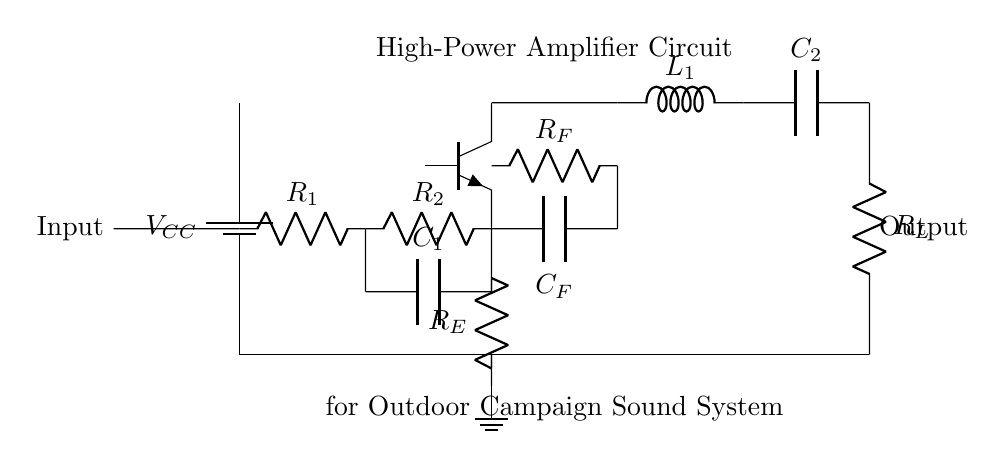What type of transistor is used in this amplifier circuit? The circuit diagram shows a transistor labeled as 'Q1' with a designation of 'Tnpn', indicating that it is a NPN transistor, which is typically used for amplifying signals in such circuits.
Answer: NPN What is the purpose of capacitor C1 in this circuit? Capacitor C1 connects in parallel with resistor R2, and it serves to block DC voltage while allowing AC signals to pass, which is essential for coupling the input signal to the transistor for amplification.
Answer: Coupling What does the symbol L1 represent in the output stage? The symbol L1 in the output stage denotes an inductor, which is used for filtering high-frequency noise from the output signal, ensuring a cleaner sound for the outdoor campaign sound system.
Answer: Inductor What is the minimum voltage required across the battery in this circuit? The circuit diagram does not specify an exact voltage; however, in general, for a high-power amplifier using NPN transistors, a minimum battery voltage of 12V to 15V is often needed to ensure proper operation and headroom for the output stages.
Answer: Twelve volts Why is resistor Rf connected in the feedback network? Resistor Rf is part of the feedback network; it provides a portion of the output back to the input through capacitor Cf. This feedback helps stabilize the amplifier gain and improve linearity, making the amplifier more stable and reducing distortion.
Answer: Stabilizing gain 